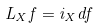<formula> <loc_0><loc_0><loc_500><loc_500>L _ { X } f = i _ { X } d f</formula> 